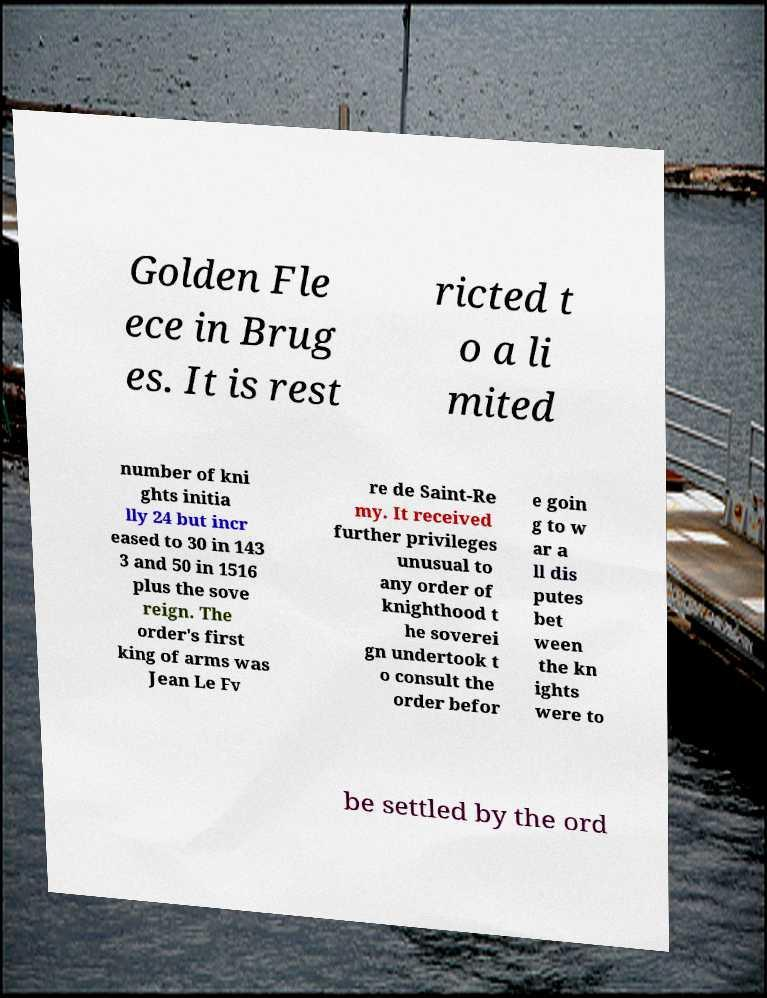Could you assist in decoding the text presented in this image and type it out clearly? Golden Fle ece in Brug es. It is rest ricted t o a li mited number of kni ghts initia lly 24 but incr eased to 30 in 143 3 and 50 in 1516 plus the sove reign. The order's first king of arms was Jean Le Fv re de Saint-Re my. It received further privileges unusual to any order of knighthood t he soverei gn undertook t o consult the order befor e goin g to w ar a ll dis putes bet ween the kn ights were to be settled by the ord 